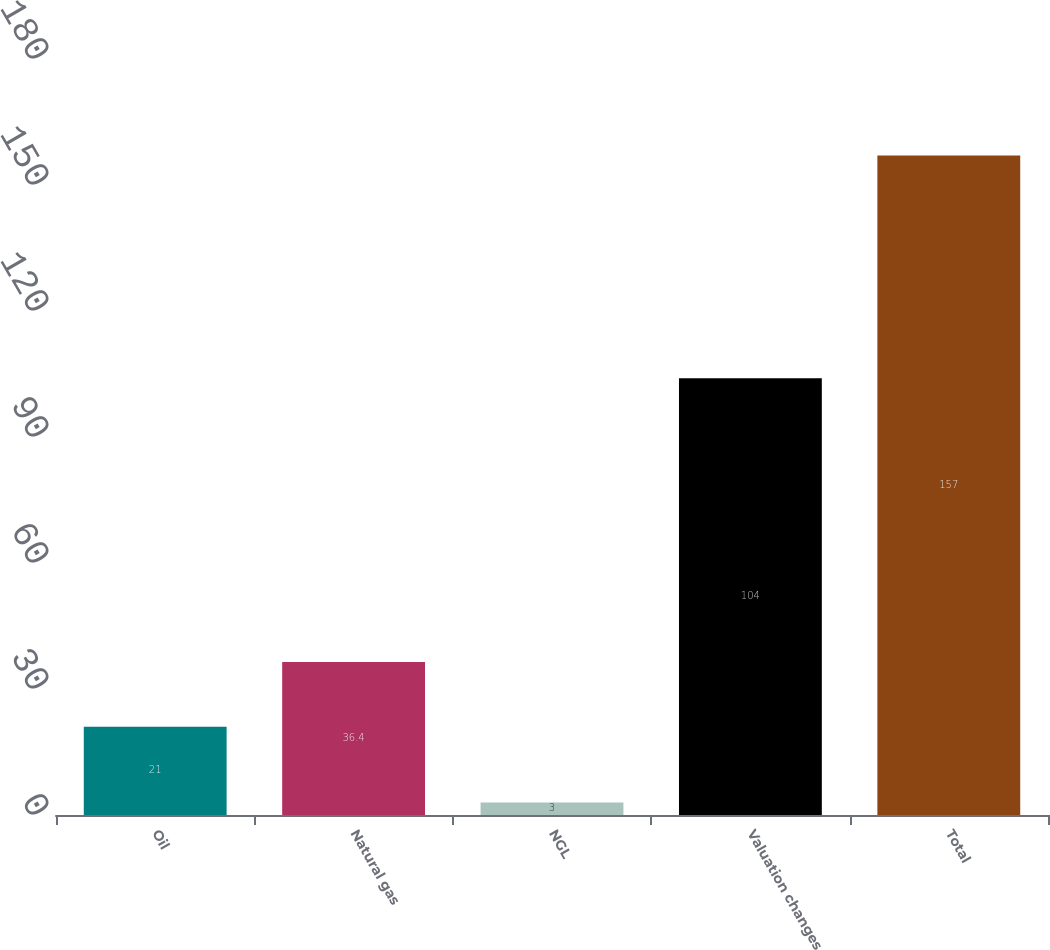<chart> <loc_0><loc_0><loc_500><loc_500><bar_chart><fcel>Oil<fcel>Natural gas<fcel>NGL<fcel>Valuation changes<fcel>Total<nl><fcel>21<fcel>36.4<fcel>3<fcel>104<fcel>157<nl></chart> 